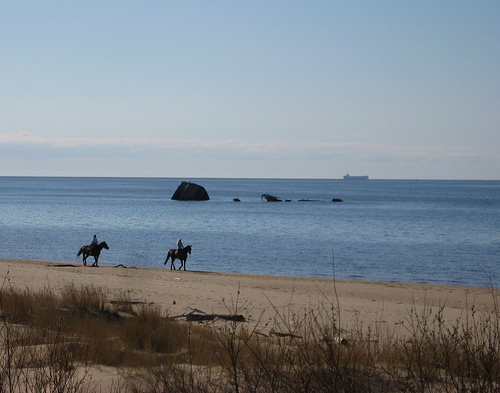Which actor has the training to do what these people are doing? Without more context about the specific training or activity being depicted in the image, it isn't possible to accurately determine which, if any, of the listed actors may have relevant training. The image shows two individuals on horseback near the shore, and none of the actors listed are specifically known for equestrian skills as a defining aspect of their careers. More information would be needed to make an informed statement regarding the actors' training in relation to this scene. 